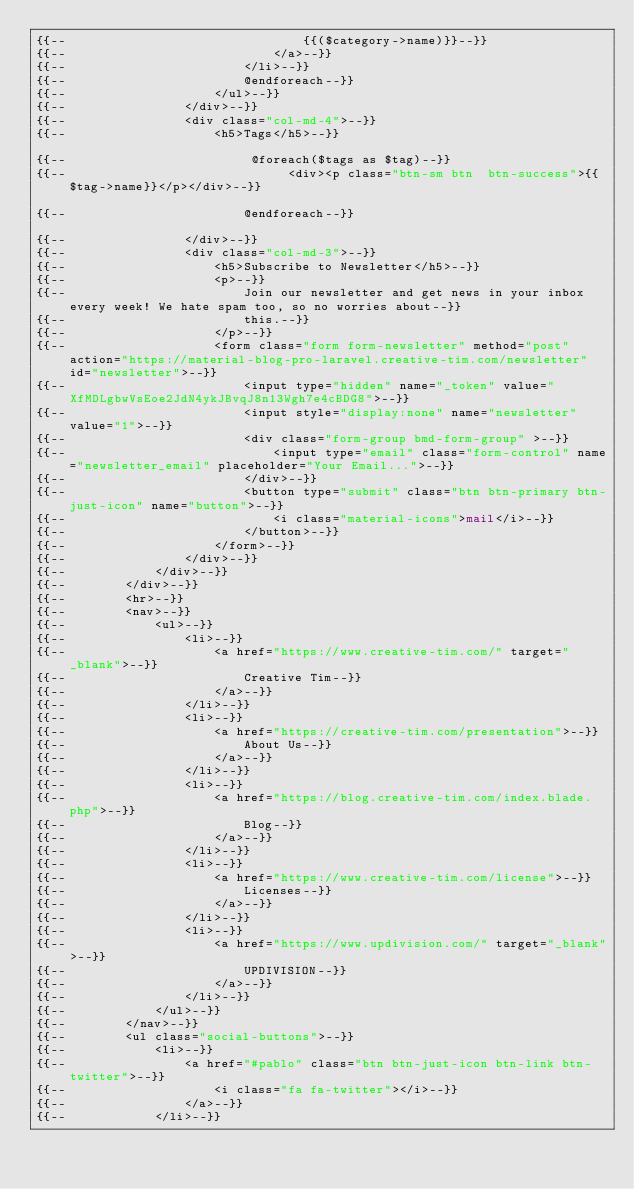<code> <loc_0><loc_0><loc_500><loc_500><_PHP_>{{--                                {{($category->name)}}--}}
{{--                            </a>--}}
{{--                        </li>--}}
{{--                        @endforeach--}}
{{--                    </ul>--}}
{{--                </div>--}}
{{--                <div class="col-md-4">--}}
{{--                    <h5>Tags</h5>--}}

{{--                         @foreach($tags as $tag)--}}
{{--                              <div><p class="btn-sm btn  btn-success">{{$tag->name}}</p></div>--}}

{{--                        @endforeach--}}

{{--                </div>--}}
{{--                <div class="col-md-3">--}}
{{--                    <h5>Subscribe to Newsletter</h5>--}}
{{--                    <p>--}}
{{--                        Join our newsletter and get news in your inbox every week! We hate spam too, so no worries about--}}
{{--                        this.--}}
{{--                    </p>--}}
{{--                    <form class="form form-newsletter" method="post" action="https://material-blog-pro-laravel.creative-tim.com/newsletter" id="newsletter">--}}
{{--                        <input type="hidden" name="_token" value="XfMDLgbwVsEoe2JdN4ykJBvqJ8n13Wgh7e4cBDG8">--}}
{{--                        <input style="display:none" name="newsletter" value="1">--}}
{{--                        <div class="form-group bmd-form-group" >--}}
{{--                            <input type="email" class="form-control" name="newsletter_email" placeholder="Your Email...">--}}
{{--                        </div>--}}
{{--                        <button type="submit" class="btn btn-primary btn-just-icon" name="button">--}}
{{--                            <i class="material-icons">mail</i>--}}
{{--                        </button>--}}
{{--                    </form>--}}
{{--                </div>--}}
{{--            </div>--}}
{{--        </div>--}}
{{--        <hr>--}}
{{--        <nav>--}}
{{--            <ul>--}}
{{--                <li>--}}
{{--                    <a href="https://www.creative-tim.com/" target="_blank">--}}
{{--                        Creative Tim--}}
{{--                    </a>--}}
{{--                </li>--}}
{{--                <li>--}}
{{--                    <a href="https://creative-tim.com/presentation">--}}
{{--                        About Us--}}
{{--                    </a>--}}
{{--                </li>--}}
{{--                <li>--}}
{{--                    <a href="https://blog.creative-tim.com/index.blade.php">--}}
{{--                        Blog--}}
{{--                    </a>--}}
{{--                </li>--}}
{{--                <li>--}}
{{--                    <a href="https://www.creative-tim.com/license">--}}
{{--                        Licenses--}}
{{--                    </a>--}}
{{--                </li>--}}
{{--                <li>--}}
{{--                    <a href="https://www.updivision.com/" target="_blank">--}}
{{--                        UPDIVISION--}}
{{--                    </a>--}}
{{--                </li>--}}
{{--            </ul>--}}
{{--        </nav>--}}
{{--        <ul class="social-buttons">--}}
{{--            <li>--}}
{{--                <a href="#pablo" class="btn btn-just-icon btn-link btn-twitter">--}}
{{--                    <i class="fa fa-twitter"></i>--}}
{{--                </a>--}}
{{--            </li>--}}</code> 